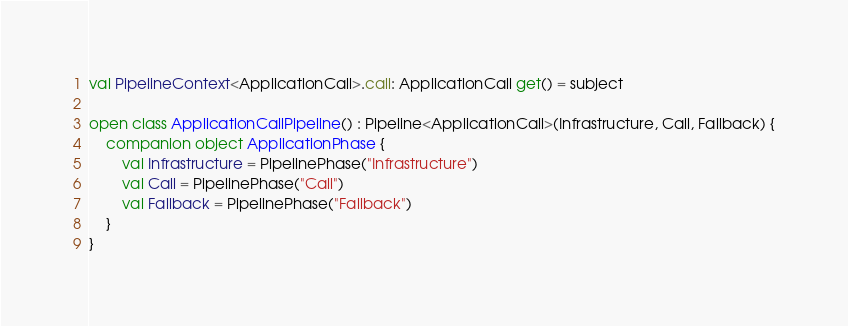<code> <loc_0><loc_0><loc_500><loc_500><_Kotlin_>
val PipelineContext<ApplicationCall>.call: ApplicationCall get() = subject

open class ApplicationCallPipeline() : Pipeline<ApplicationCall>(Infrastructure, Call, Fallback) {
    companion object ApplicationPhase {
        val Infrastructure = PipelinePhase("Infrastructure")
        val Call = PipelinePhase("Call")
        val Fallback = PipelinePhase("Fallback")
    }
}
</code> 